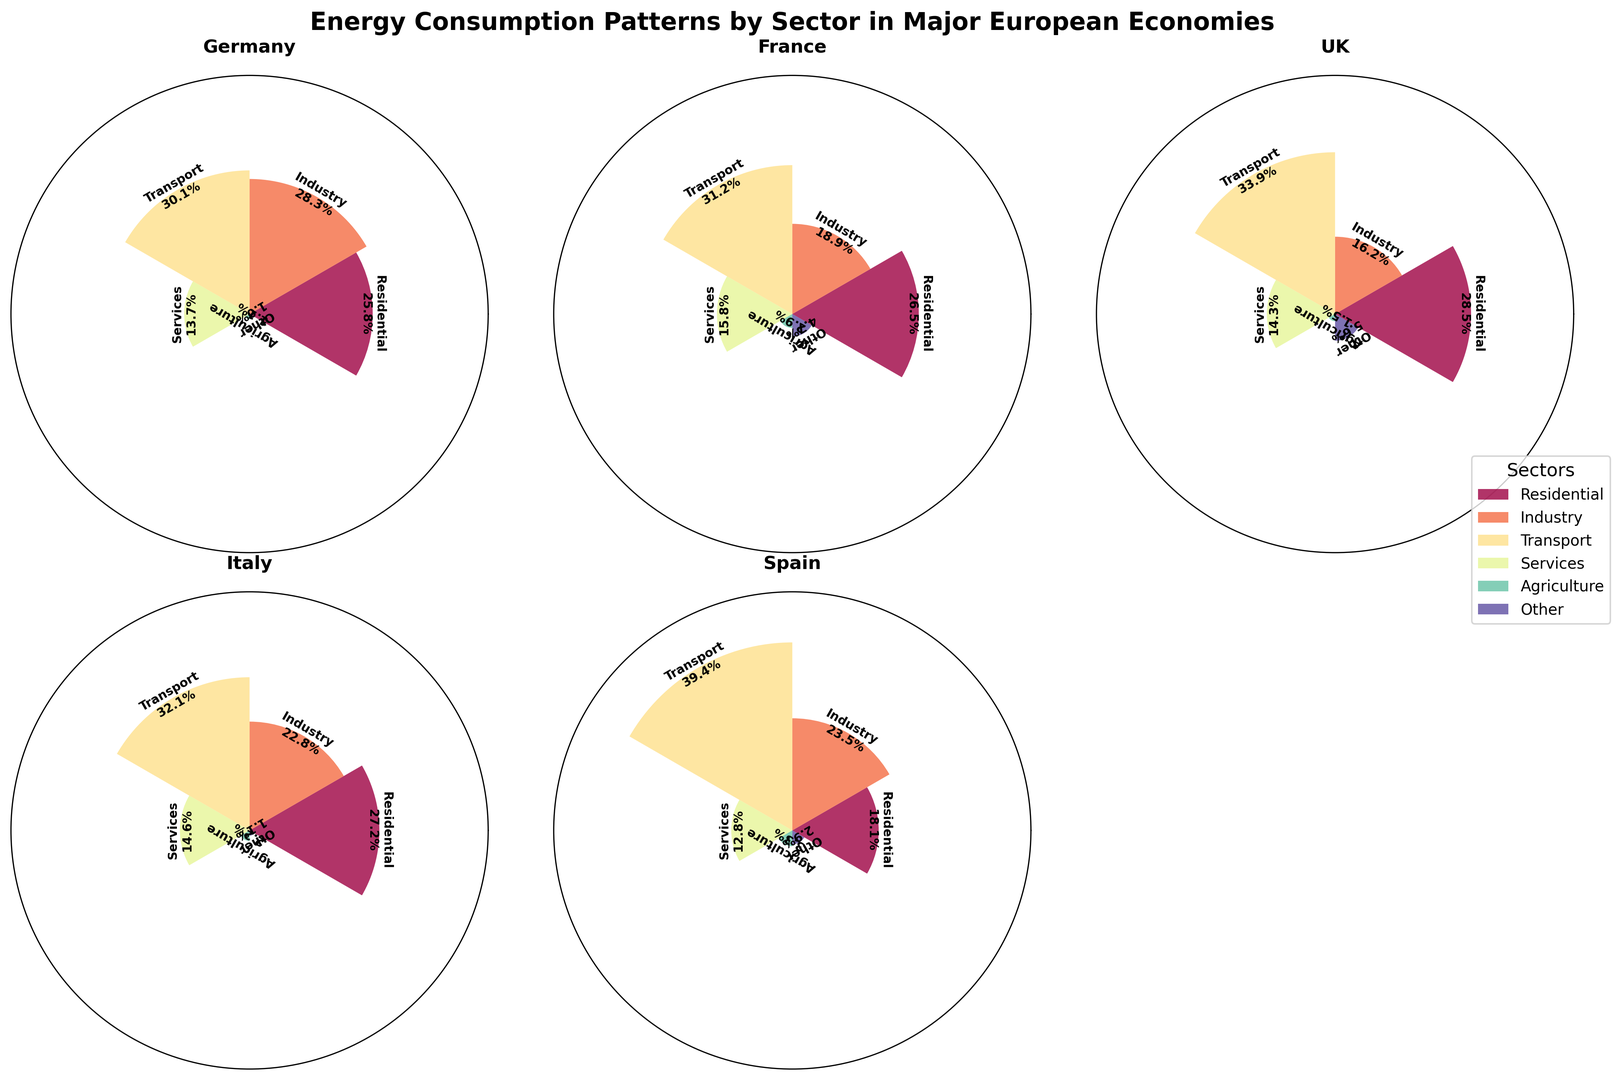Which sector has the highest energy consumption in the UK? Observe all the sectors in the UK's ring chart. The tallest bar corresponds to the Transport sector.
Answer: Transport Which country has the lowest percentage of energy consumption in the Residential sector? Compare the heights and labels of the bars for the Residential sector across all countries. Spain has the smallest bar for Residential.
Answer: Spain What is the combined energy consumption percentage of the Industry and Services sectors in Italy? Locate the corresponding bars for the Industry and Services sectors in Italy and sum their heights: 22.8% + 14.6%.
Answer: 37.4% Which country allocates more energy consumption to Agriculture than to Other sectors? Compare the Agriculture and Other sectors' heights in each country's chart. Only France shows a higher energy consumption in Agriculture (2.9%) compared to Other (4.7%).
Answer: France Is the energy consumption for the Services sector higher in Germany or the UK? Compare the heights of the Services sector bars in Germany and the UK. The UK's bar (14.3%) is taller than Germany's (13.7%).
Answer: UK Which country has the most evenly distributed energy consumption across all sectors? Look for the country with bars of more similar heights. France has less variation in bar heights compared to others.
Answer: France How much more energy is consumed by the Transport sector compared to the Residential sector in Spain? Calculate the difference between the Transport (39.4%) and Residential (18.1%) sector bars for Spain: 39.4% - 18.1%.
Answer: 21.3% Which sector consumes the least energy in Germany? Identify the shortest bar in Germany's ring chart, which is the 'Other' sector.
Answer: Other Determine the average energy consumption for the Transport sector across all countries. Add the percentages for the Transport sector in all countries and divide by 5: (30.1% + 31.2% + 33.9% + 32.1% + 39.4%) / 5.
Answer: 33.34% In which country is the Residential sector’s energy consumption closest to the average percentage across all countries? First, calculate the average Residential consumption: (25.8% + 26.5% + 28.5% + 27.2% + 18.1%) / 5 = 25.22%. Then, find the country closest to this value. Germany is closest with 25.8%.
Answer: Germany 